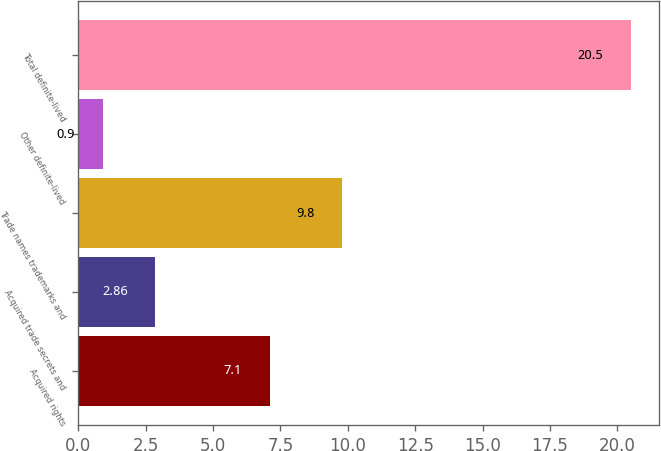<chart> <loc_0><loc_0><loc_500><loc_500><bar_chart><fcel>Acquired rights<fcel>Acquired trade secrets and<fcel>Trade names trademarks and<fcel>Other definite-lived<fcel>Total definite-lived<nl><fcel>7.1<fcel>2.86<fcel>9.8<fcel>0.9<fcel>20.5<nl></chart> 